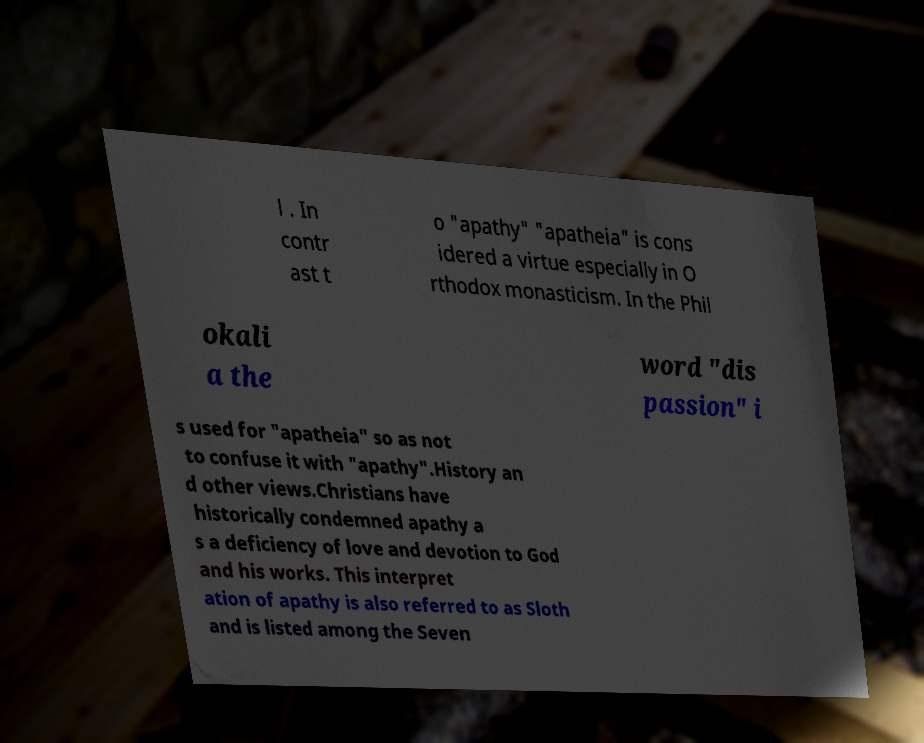Could you extract and type out the text from this image? l . In contr ast t o "apathy" "apatheia" is cons idered a virtue especially in O rthodox monasticism. In the Phil okali a the word "dis passion" i s used for "apatheia" so as not to confuse it with "apathy".History an d other views.Christians have historically condemned apathy a s a deficiency of love and devotion to God and his works. This interpret ation of apathy is also referred to as Sloth and is listed among the Seven 